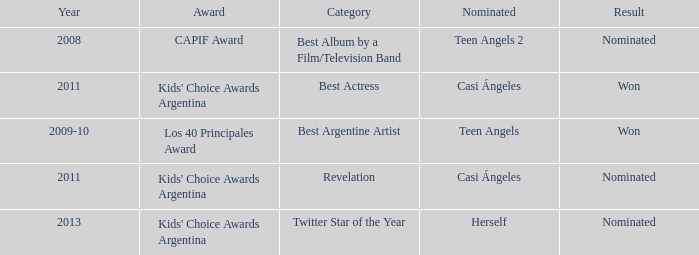What year was Teen Angels 2 nominated? 2008.0. 